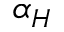<formula> <loc_0><loc_0><loc_500><loc_500>\alpha _ { H }</formula> 